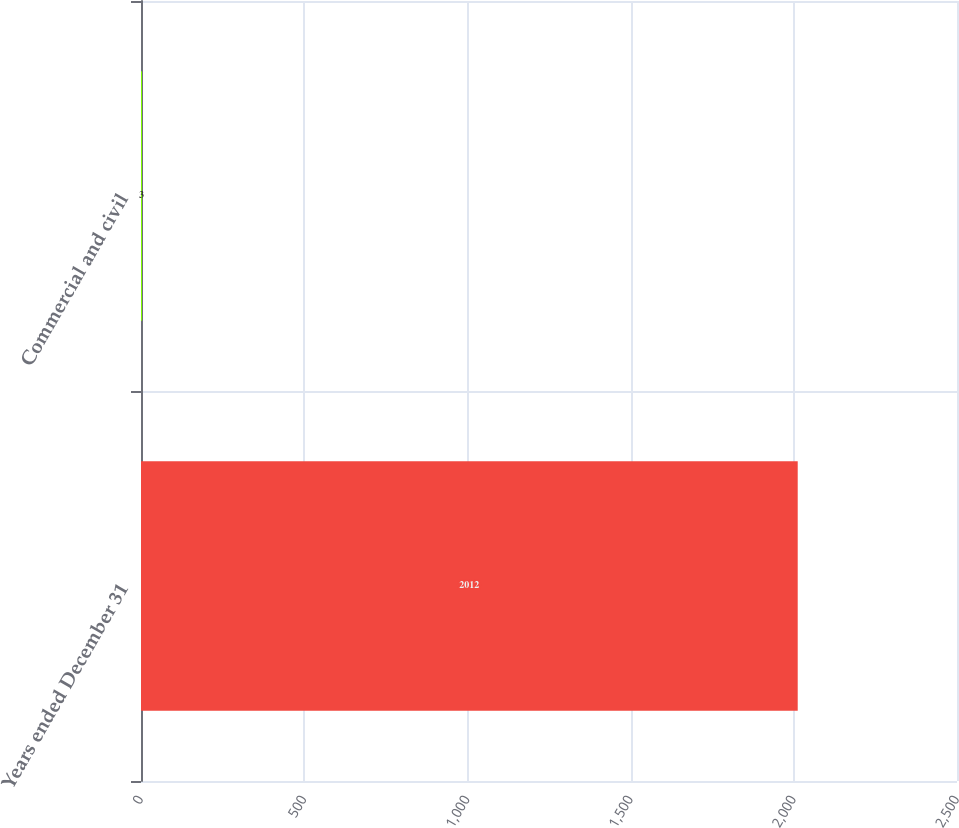<chart> <loc_0><loc_0><loc_500><loc_500><bar_chart><fcel>Years ended December 31<fcel>Commercial and civil<nl><fcel>2012<fcel>3<nl></chart> 